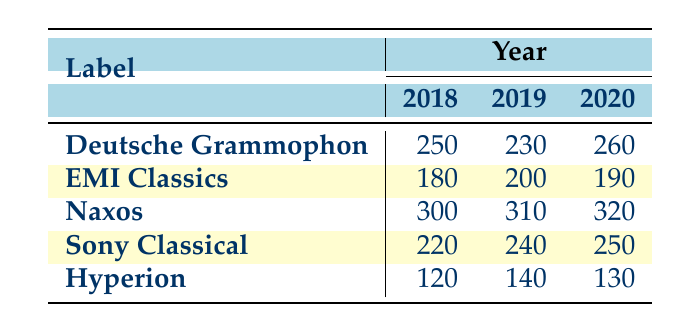What is the total number of recordings for Naxos in 2020? Referring to the table, we find the value for Naxos in the year 2020, which is 320 recordings.
Answer: 320 Which label has the highest number of recordings in 2019? Looking at the 2019 column, Naxos has 310 recordings which is higher than the other labels: Deutsche Grammophon (230), EMI Classics (200), Sony Classical (240), and Hyperion (140).
Answer: Naxos What is the average number of recordings for Deutsche Grammophon across the three years? The values for Deutsche Grammophon are 250 (2018), 230 (2019), and 260 (2020). Adding these gives 250 + 230 + 260 = 740, and dividing by 3 (the number of years) gives 740 / 3 = 246.67.
Answer: 246.67 Did EMI Classics ever record more than 200 recordings in any of the three years? Looking at the table, in 2018 EMI Classics had 180, in 2019 it had 200, and in 2020 it had 190. None of these values exceed 200.
Answer: No How many more recordings did Sony Classical have in 2020 compared to 2018? Sony Classical recorded 250 in 2020 and 220 in 2018. The difference is calculated as 250 - 220 = 30.
Answer: 30 Which label consistently recorded the least number of recordings in all three years? Checking the values, Hyperion had 120 (2018), 140 (2019), and 130 (2020), which are lower than all other labels for those years.
Answer: Hyperion What is the total number of recordings for all labels combined in 2018? Summing the recordings: Deutsche Grammophon (250) + EMI Classics (180) + Naxos (300) + Sony Classical (220) + Hyperion (120) gives 250 + 180 + 300 + 220 + 120 = 1070.
Answer: 1070 Did any label have the same number of recordings in 2018 and 2020? Comparing the table, no label shows the same number of recordings in both years. For example, Deutsche Grammophon had 250 in 2018 and 260 in 2020; EMI Classics had 180 in 2018 and 190 in 2020, and so forth.
Answer: No 